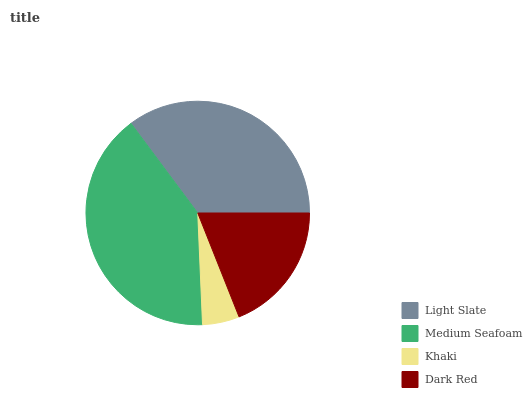Is Khaki the minimum?
Answer yes or no. Yes. Is Medium Seafoam the maximum?
Answer yes or no. Yes. Is Medium Seafoam the minimum?
Answer yes or no. No. Is Khaki the maximum?
Answer yes or no. No. Is Medium Seafoam greater than Khaki?
Answer yes or no. Yes. Is Khaki less than Medium Seafoam?
Answer yes or no. Yes. Is Khaki greater than Medium Seafoam?
Answer yes or no. No. Is Medium Seafoam less than Khaki?
Answer yes or no. No. Is Light Slate the high median?
Answer yes or no. Yes. Is Dark Red the low median?
Answer yes or no. Yes. Is Medium Seafoam the high median?
Answer yes or no. No. Is Medium Seafoam the low median?
Answer yes or no. No. 